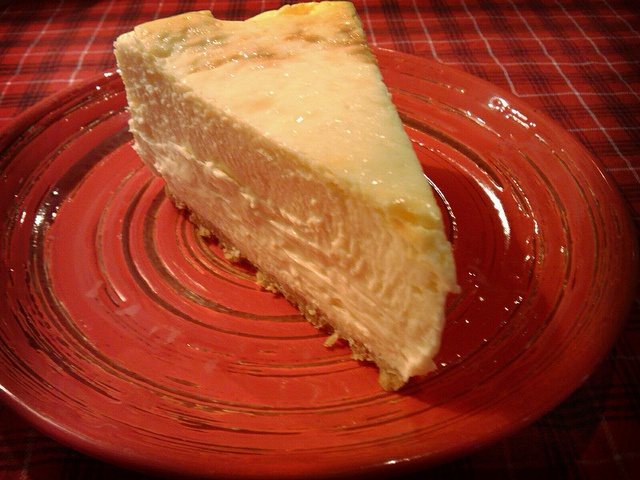Describe the objects in this image and their specific colors. I can see dining table in brown, maroon, red, tan, and black tones and cake in black, tan, red, and salmon tones in this image. 